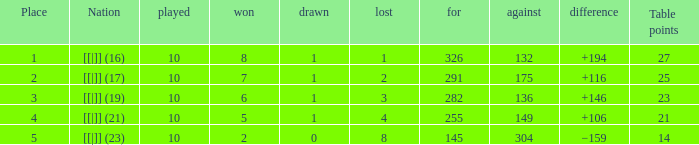Parse the full table. {'header': ['Place', 'Nation', 'played', 'won', 'drawn', 'lost', 'for', 'against', 'difference', 'Table points'], 'rows': [['1', '[[|]] (16)', '10', '8', '1', '1', '326', '132', '+194', '27'], ['2', '[[|]] (17)', '10', '7', '1', '2', '291', '175', '+116', '25'], ['3', '[[|]] (19)', '10', '6', '1', '3', '282', '136', '+146', '23'], ['4', '[[|]] (21)', '10', '5', '1', '4', '255', '149', '+106', '21'], ['5', '[[|]] (23)', '10', '2', '0', '8', '145', '304', '−159', '14']]}  How many table points are listed for the deficit is +194?  1.0. 